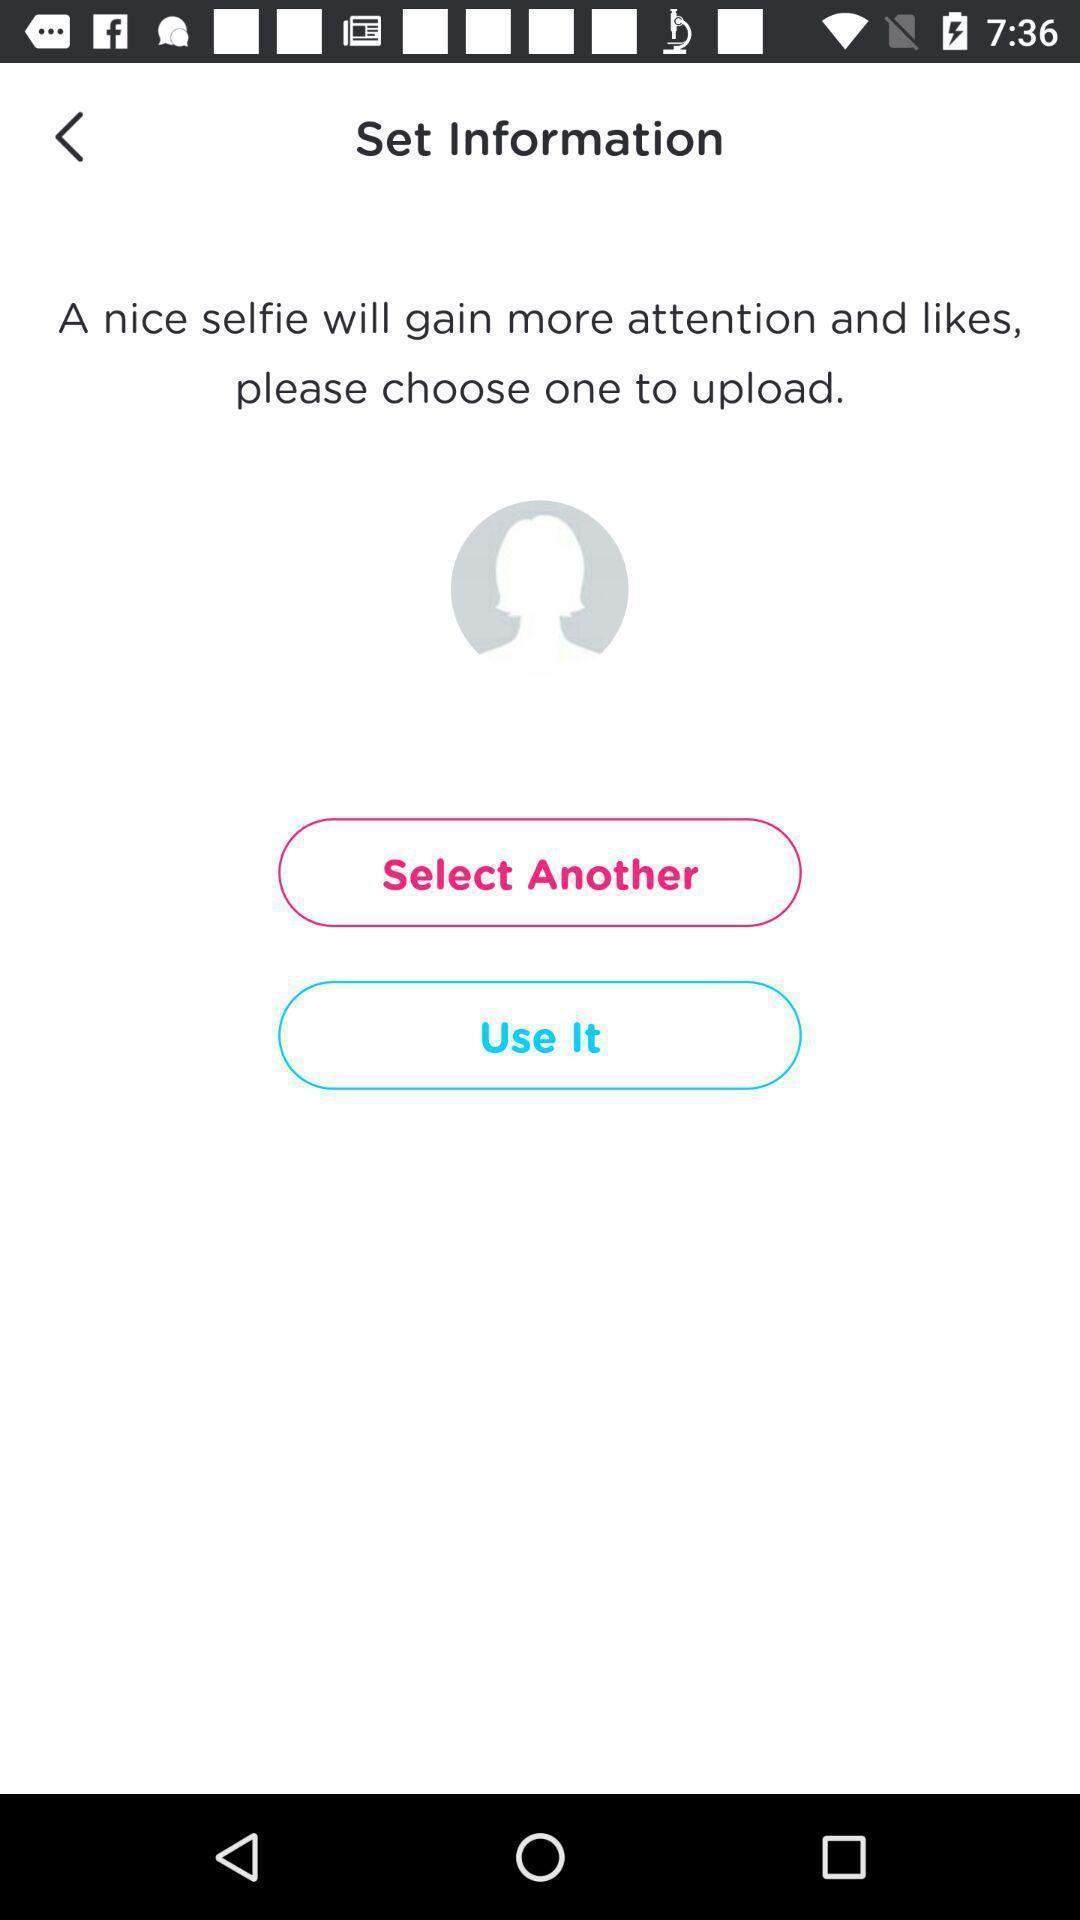Summarize the main components in this picture. Screen displaying options to upload user information. 